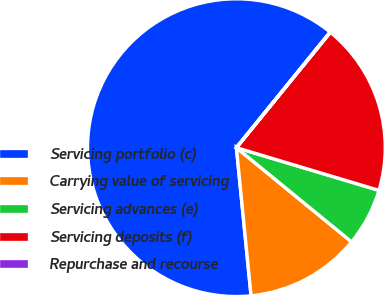Convert chart. <chart><loc_0><loc_0><loc_500><loc_500><pie_chart><fcel>Servicing portfolio (c)<fcel>Carrying value of servicing<fcel>Servicing advances (e)<fcel>Servicing deposits (f)<fcel>Repurchase and recourse<nl><fcel>62.41%<fcel>12.52%<fcel>6.28%<fcel>18.75%<fcel>0.04%<nl></chart> 